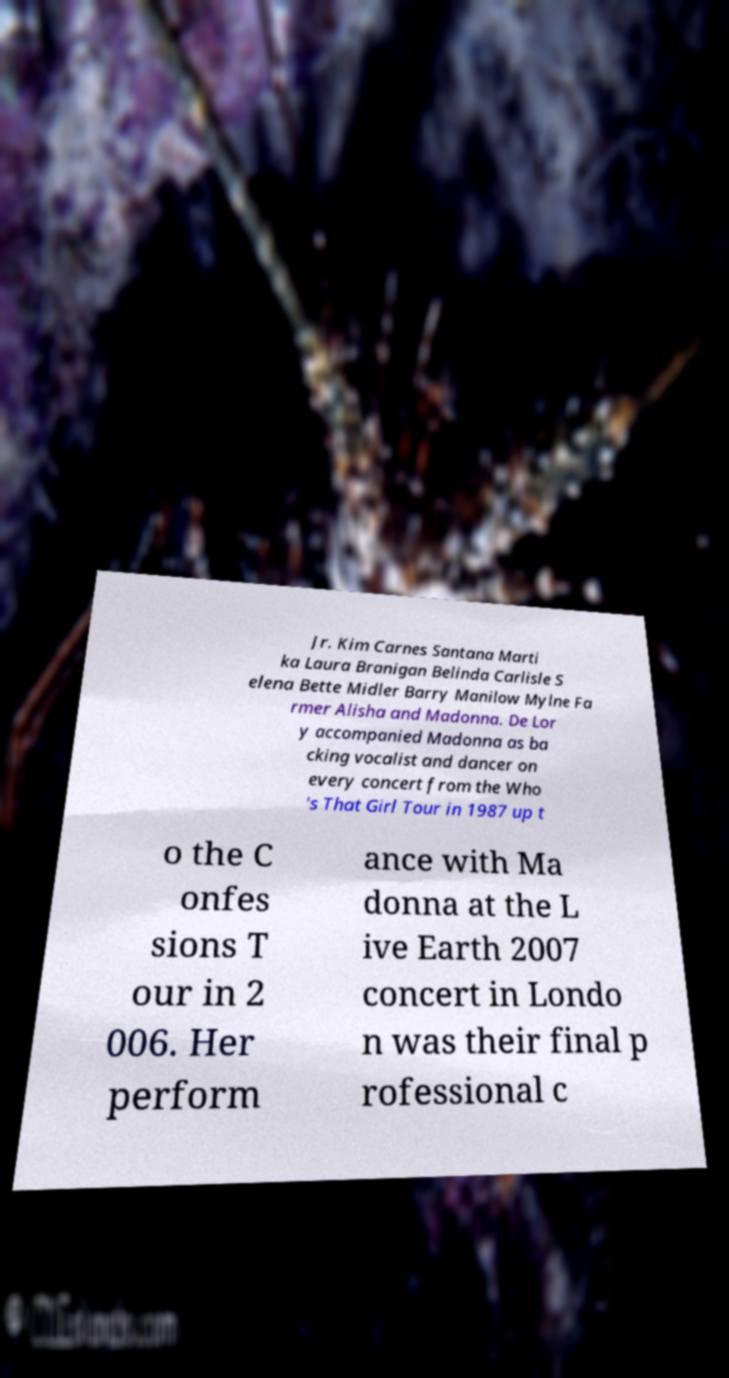Please read and relay the text visible in this image. What does it say? Jr. Kim Carnes Santana Marti ka Laura Branigan Belinda Carlisle S elena Bette Midler Barry Manilow Mylne Fa rmer Alisha and Madonna. De Lor y accompanied Madonna as ba cking vocalist and dancer on every concert from the Who 's That Girl Tour in 1987 up t o the C onfes sions T our in 2 006. Her perform ance with Ma donna at the L ive Earth 2007 concert in Londo n was their final p rofessional c 